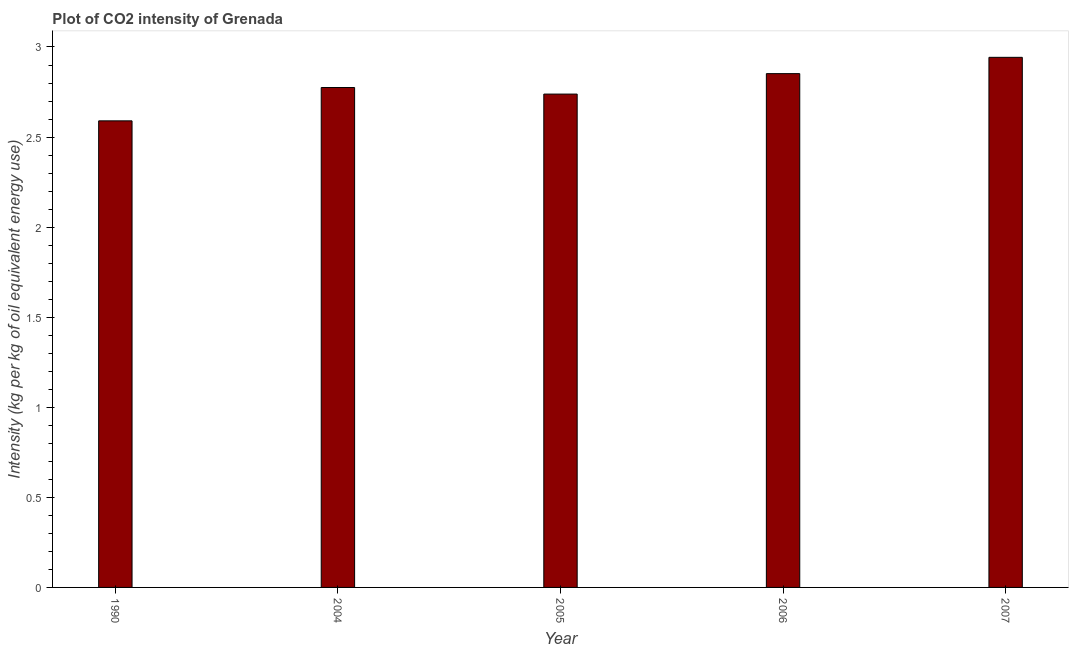Does the graph contain grids?
Provide a succinct answer. No. What is the title of the graph?
Keep it short and to the point. Plot of CO2 intensity of Grenada. What is the label or title of the Y-axis?
Provide a succinct answer. Intensity (kg per kg of oil equivalent energy use). What is the co2 intensity in 2007?
Give a very brief answer. 2.94. Across all years, what is the maximum co2 intensity?
Ensure brevity in your answer.  2.94. Across all years, what is the minimum co2 intensity?
Give a very brief answer. 2.59. In which year was the co2 intensity maximum?
Offer a terse response. 2007. In which year was the co2 intensity minimum?
Keep it short and to the point. 1990. What is the sum of the co2 intensity?
Offer a terse response. 13.9. What is the difference between the co2 intensity in 2004 and 2007?
Offer a terse response. -0.17. What is the average co2 intensity per year?
Ensure brevity in your answer.  2.78. What is the median co2 intensity?
Provide a succinct answer. 2.78. Do a majority of the years between 1990 and 2007 (inclusive) have co2 intensity greater than 1.7 kg?
Keep it short and to the point. Yes. Is the difference between the co2 intensity in 2005 and 2006 greater than the difference between any two years?
Your answer should be very brief. No. What is the difference between the highest and the second highest co2 intensity?
Give a very brief answer. 0.09. What is the difference between the highest and the lowest co2 intensity?
Offer a very short reply. 0.35. In how many years, is the co2 intensity greater than the average co2 intensity taken over all years?
Offer a very short reply. 2. How many bars are there?
Make the answer very short. 5. What is the difference between two consecutive major ticks on the Y-axis?
Offer a terse response. 0.5. Are the values on the major ticks of Y-axis written in scientific E-notation?
Offer a very short reply. No. What is the Intensity (kg per kg of oil equivalent energy use) in 1990?
Provide a succinct answer. 2.59. What is the Intensity (kg per kg of oil equivalent energy use) of 2004?
Keep it short and to the point. 2.78. What is the Intensity (kg per kg of oil equivalent energy use) of 2005?
Your response must be concise. 2.74. What is the Intensity (kg per kg of oil equivalent energy use) of 2006?
Give a very brief answer. 2.85. What is the Intensity (kg per kg of oil equivalent energy use) of 2007?
Provide a short and direct response. 2.94. What is the difference between the Intensity (kg per kg of oil equivalent energy use) in 1990 and 2004?
Offer a very short reply. -0.18. What is the difference between the Intensity (kg per kg of oil equivalent energy use) in 1990 and 2005?
Give a very brief answer. -0.15. What is the difference between the Intensity (kg per kg of oil equivalent energy use) in 1990 and 2006?
Your response must be concise. -0.26. What is the difference between the Intensity (kg per kg of oil equivalent energy use) in 1990 and 2007?
Give a very brief answer. -0.35. What is the difference between the Intensity (kg per kg of oil equivalent energy use) in 2004 and 2005?
Provide a short and direct response. 0.04. What is the difference between the Intensity (kg per kg of oil equivalent energy use) in 2004 and 2006?
Your answer should be very brief. -0.08. What is the difference between the Intensity (kg per kg of oil equivalent energy use) in 2004 and 2007?
Your answer should be compact. -0.17. What is the difference between the Intensity (kg per kg of oil equivalent energy use) in 2005 and 2006?
Provide a succinct answer. -0.11. What is the difference between the Intensity (kg per kg of oil equivalent energy use) in 2005 and 2007?
Provide a succinct answer. -0.2. What is the difference between the Intensity (kg per kg of oil equivalent energy use) in 2006 and 2007?
Offer a very short reply. -0.09. What is the ratio of the Intensity (kg per kg of oil equivalent energy use) in 1990 to that in 2004?
Your answer should be very brief. 0.93. What is the ratio of the Intensity (kg per kg of oil equivalent energy use) in 1990 to that in 2005?
Provide a short and direct response. 0.95. What is the ratio of the Intensity (kg per kg of oil equivalent energy use) in 1990 to that in 2006?
Offer a terse response. 0.91. What is the ratio of the Intensity (kg per kg of oil equivalent energy use) in 1990 to that in 2007?
Your answer should be compact. 0.88. What is the ratio of the Intensity (kg per kg of oil equivalent energy use) in 2004 to that in 2006?
Make the answer very short. 0.97. What is the ratio of the Intensity (kg per kg of oil equivalent energy use) in 2004 to that in 2007?
Your answer should be compact. 0.94. What is the ratio of the Intensity (kg per kg of oil equivalent energy use) in 2005 to that in 2006?
Your answer should be very brief. 0.96. What is the ratio of the Intensity (kg per kg of oil equivalent energy use) in 2006 to that in 2007?
Give a very brief answer. 0.97. 